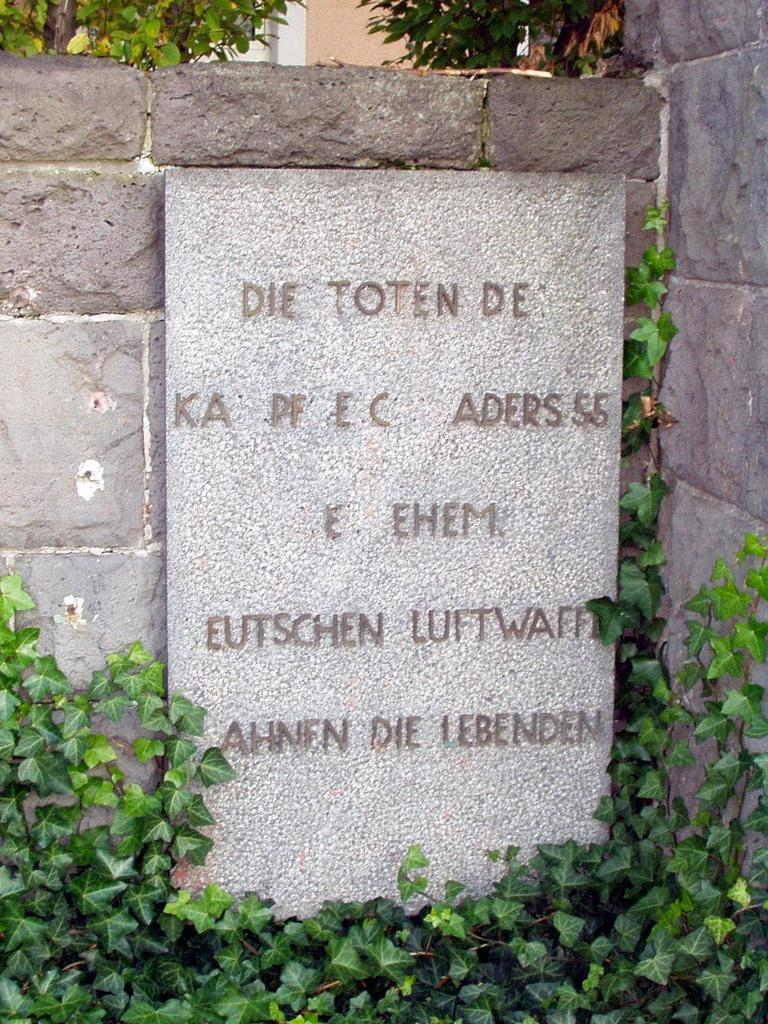What is present on the wall in the image? There is text and creepers on the wall in the image. Can you describe the type of text on the wall? Unfortunately, the specific content of the text cannot be determined from the image. What else can be seen in the image besides the wall? There are trees visible in the image. What type of bone can be seen in the image? There is no bone present in the image. Is there a carpenter in the image who made the wall? The image does not provide information about who made the wall or if a carpenter was involved. Can you see any agreements being signed in the image? There is no indication of any agreements being signed in the image. 